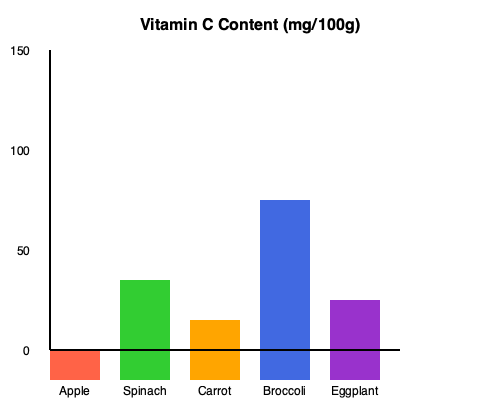As a green grocer at the local farmers market, you often educate customers about the nutritional content of various produce. Based on the bar graph showing Vitamin C content in different fruits and vegetables, which item would you recommend to a customer looking for the highest Vitamin C content per 100g? To determine which item has the highest Vitamin C content, we need to compare the heights of the bars for each fruit and vegetable:

1. Apple: The bar reaches approximately 30 mg/100g
2. Spinach: The bar reaches approximately 100 mg/100g
3. Carrot: The bar reaches approximately 60 mg/100g
4. Broccoli: The bar reaches approximately 180 mg/100g
5. Eggplant: The bar reaches approximately 80 mg/100g

By comparing these values, we can see that broccoli has the tallest bar, reaching about 180 mg/100g. This indicates that broccoli has the highest Vitamin C content among the fruits and vegetables shown in the graph.

As a green grocer, you would recommend broccoli to a customer looking for the produce with the highest Vitamin C content based on this data.
Answer: Broccoli 